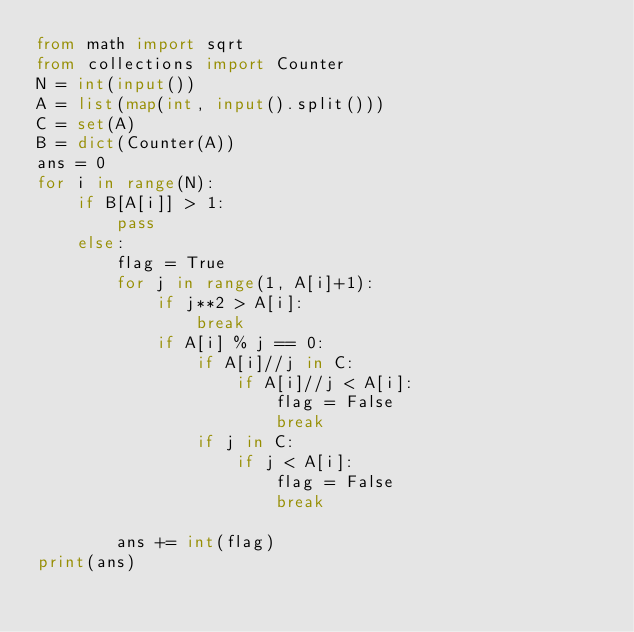<code> <loc_0><loc_0><loc_500><loc_500><_Python_>from math import sqrt
from collections import Counter
N = int(input())
A = list(map(int, input().split()))
C = set(A)
B = dict(Counter(A))
ans = 0
for i in range(N):
    if B[A[i]] > 1:
        pass
    else:
        flag = True
        for j in range(1, A[i]+1):
            if j**2 > A[i]:
                break
            if A[i] % j == 0:
                if A[i]//j in C:
                    if A[i]//j < A[i]:
                        flag = False
                        break
                if j in C:
                    if j < A[i]:
                        flag = False
                        break

        ans += int(flag)
print(ans)</code> 